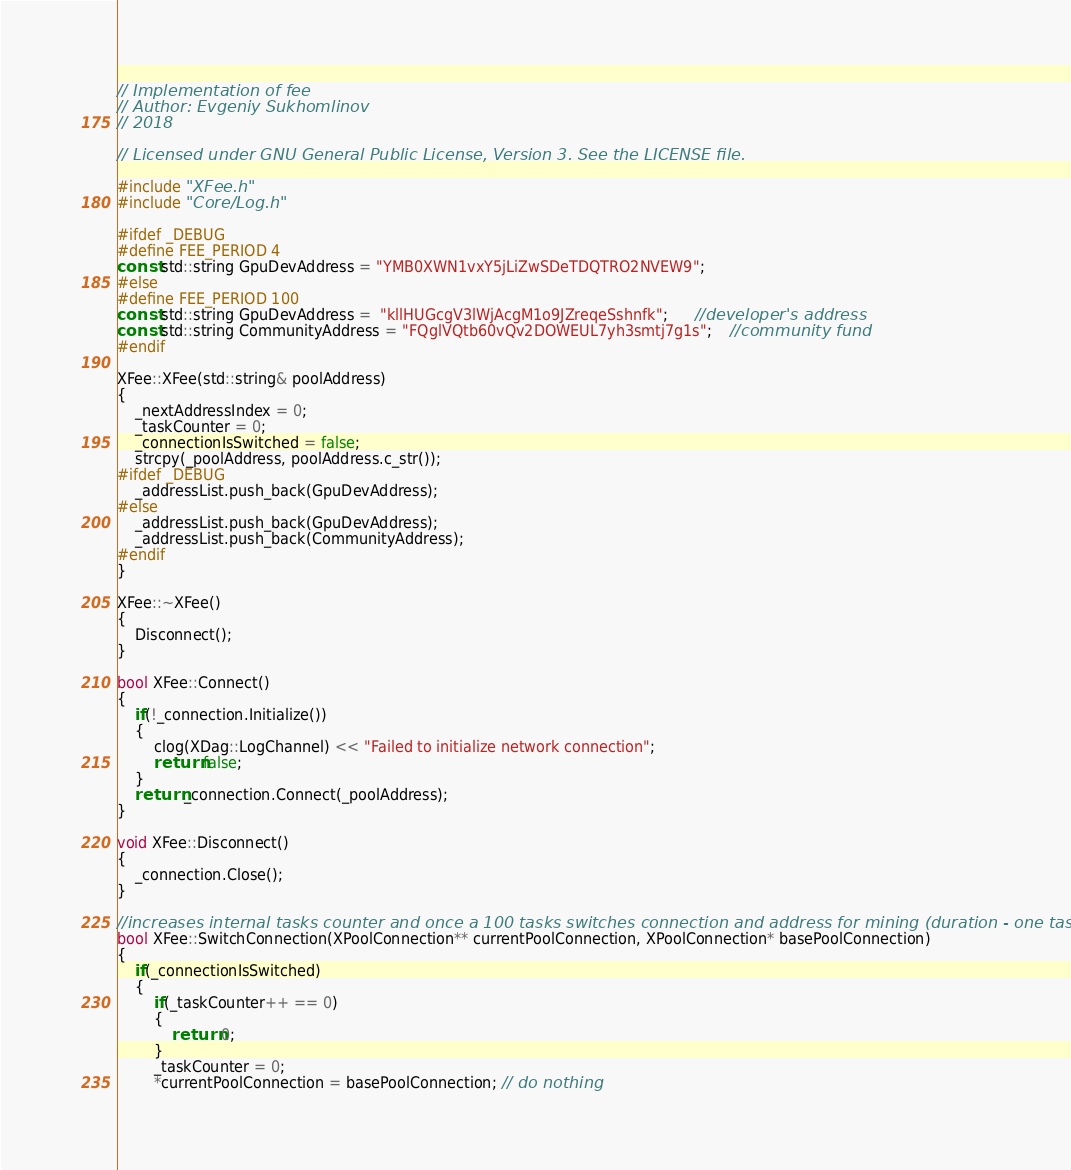Convert code to text. <code><loc_0><loc_0><loc_500><loc_500><_C++_>// Implementation of fee
// Author: Evgeniy Sukhomlinov
// 2018

// Licensed under GNU General Public License, Version 3. See the LICENSE file.

#include "XFee.h"
#include "Core/Log.h"

#ifdef _DEBUG
#define FEE_PERIOD 4
const std::string GpuDevAddress = "YMB0XWN1vxY5jLiZwSDeTDQTRO2NVEW9";
#else
#define FEE_PERIOD 100
const std::string GpuDevAddress =  "kllHUGcgV3lWjAcgM1o9JZreqeSshnfk";      //developer's address
const std::string CommunityAddress = "FQglVQtb60vQv2DOWEUL7yh3smtj7g1s";    //community fund
#endif

XFee::XFee(std::string& poolAddress)
{
    _nextAddressIndex = 0;
    _taskCounter = 0;
    _connectionIsSwitched = false;
    strcpy(_poolAddress, poolAddress.c_str());
#ifdef _DEBUG
    _addressList.push_back(GpuDevAddress);
#else
    _addressList.push_back(GpuDevAddress);
    _addressList.push_back(CommunityAddress);
#endif
}

XFee::~XFee()
{
    Disconnect();
}

bool XFee::Connect()
{
    if(!_connection.Initialize())
    {
        clog(XDag::LogChannel) << "Failed to initialize network connection";
        return false;
    }
    return _connection.Connect(_poolAddress);
}

void XFee::Disconnect()
{
    _connection.Close();
}

//increases internal tasks counter and once a 100 tasks switches connection and address for mining (duration - one task)
bool XFee::SwitchConnection(XPoolConnection** currentPoolConnection, XPoolConnection* basePoolConnection)
{
    if(_connectionIsSwitched)
    {
        if(_taskCounter++ == 0)
        {
            return 0;
        }
        _taskCounter = 0;
        *currentPoolConnection = basePoolConnection; // do nothing</code> 